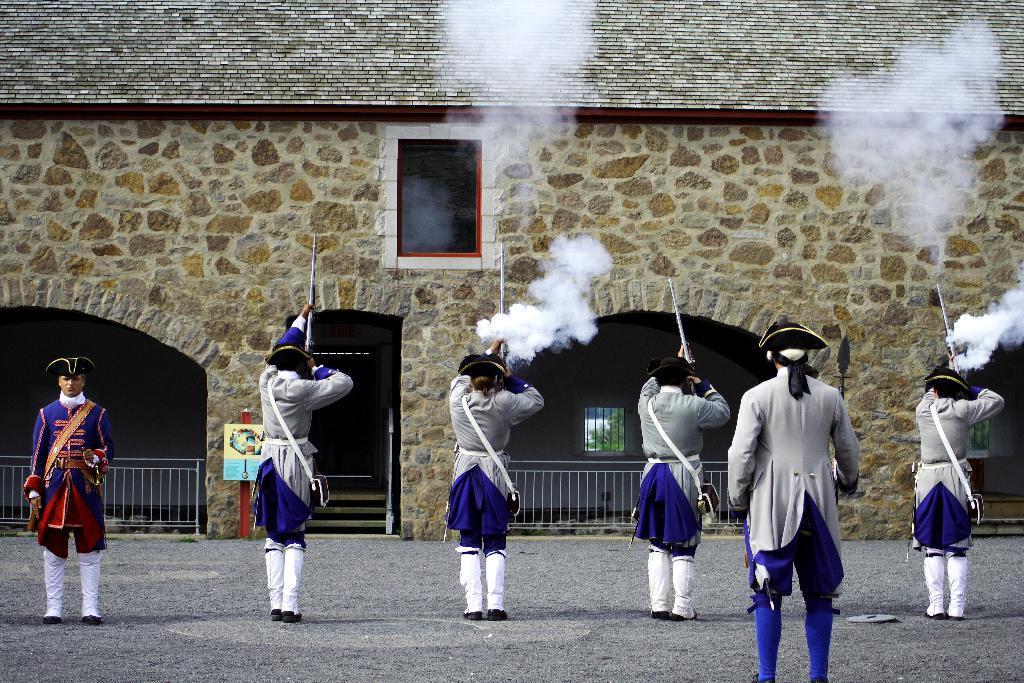How would you summarize this image in a sentence or two? In the foreground, I can see a group of people are holding guns in their hand and two persons are standing. In the background, I can see a building, smoke and a fence. This image taken, maybe during a day. 